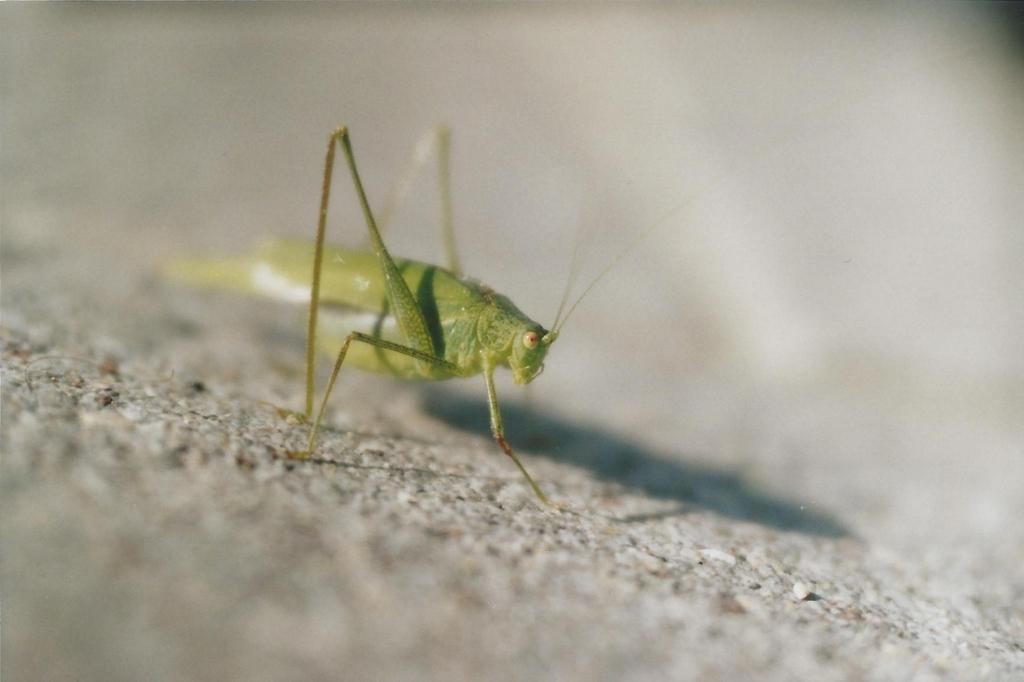What type of creature can be seen in the image? There is an insect in the image. Can you describe the insect's location in the image? The insect may be on the ground in the image. What time of day might the image have been taken? The image was likely taken during the day, as there is sufficient light to see the insect. How does the insect train for its upcoming marathon in the image? There is no indication in the image that the insect is training for a marathon or any other event. What is the insect's reaction to suddenly falling from a great height in the image? There is no indication in the image that the insect is falling or has fallen from any height. 